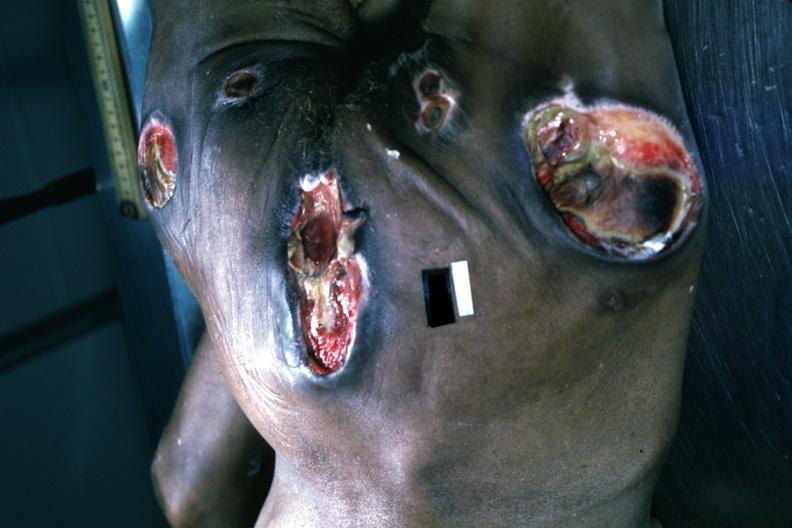does this image show large necrotic ulcers over sacrum buttocks and hips?
Answer the question using a single word or phrase. Yes 